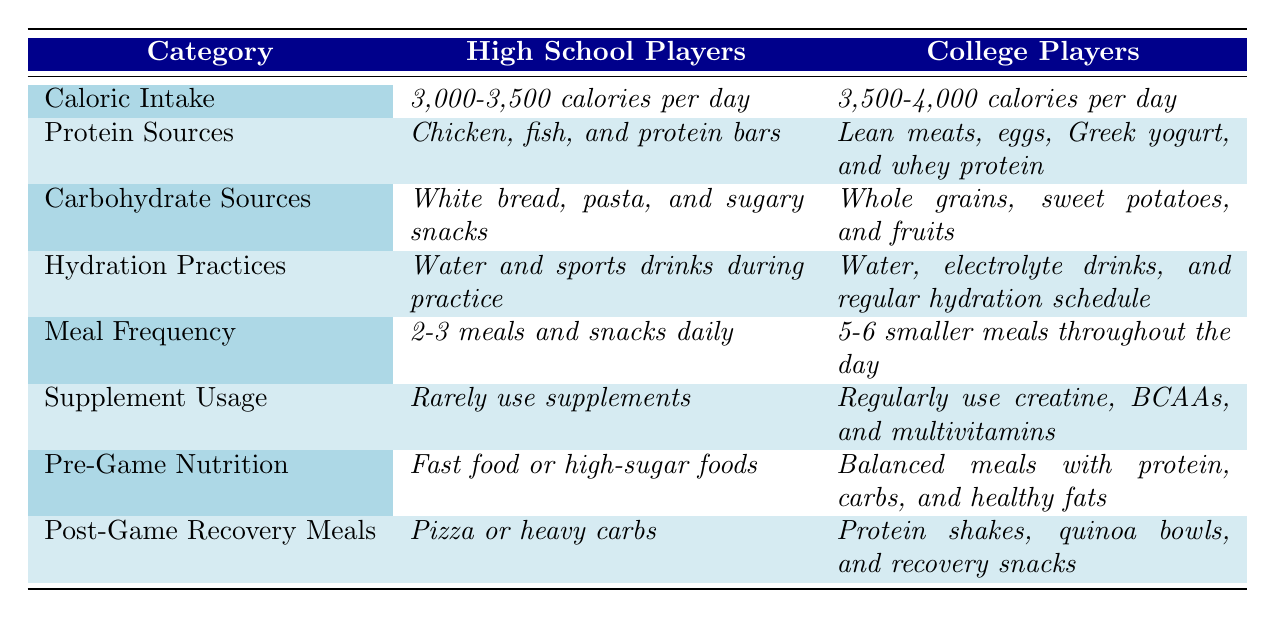What is the caloric intake range for college players? The table lists the caloric intake for college players as "_3,500-4,000 calories per day_."
Answer: 3,500-4,000 calories per day How many meals do college players eat compared to high school players? The table states that college players eat "_5-6 smaller meals throughout the day_," while high school players eat "_2-3 meals and snacks daily._"
Answer: College players eat more meals True or False: High school players regularly use protein supplements. The table indicates high school players "_rarely use supplements_," which implies they do not regularly use them.
Answer: False What is the difference in meal frequency between high school and college players? High school players have a meal frequency of "_2-3 meals and snacks daily_," while college players have "_5-6 smaller meals throughout the day_." The difference in meal frequency is between 2-3 and 5-6, which indicates college players have 2-3 more meals.
Answer: College players have 2-3 more meals What are the primary protein sources for high school players compared to college players? The table shows that high school players primarily consume "_Chicken, fish, and protein bars_," whereas college players consume "_Lean meats, eggs, Greek yogurt, and whey protein_."
Answer: Chicken, fish, and protein bars vs. lean meats, eggs, Greek yogurt, and whey protein What nutritional change occurs in carbohydrate sources when comparing high school and college players? High school players mainly consume "_White bread, pasta, and sugary snacks_," while college players eat "_Whole grains, sweet potatoes, and fruits_." This indicates a shift from less nutritious carbs to healthier options.
Answer: They switch to healthier carbohydrate sources How often do college players hydrate compared to high school players? High school players hydrate with "_Water and sports drinks during practice_," but college players have a "_Water, electrolyte drinks, and regular hydration schedule_," indicating a more structured hydration routine.
Answer: College players hydrate more regularly Are college players likely to eat fast food before a game? The table shows that high school players consume "_Fast food or high-sugar foods_," whereas college players focus on "_Balanced meals with protein, carbs, and healthy fats_," indicating college players are less likely to eat fast food.
Answer: No, college players are less likely to eat fast food What type of recovery meal do college players prefer after a game compared to high school players? High school players tend to eat "_Pizza or heavy carbs_," while college players prefer "_Protein shakes, quinoa bowls, and recovery snacks_," highlighting a shift towards more nutritious recovery options.
Answer: College players prefer healthier recovery meals 